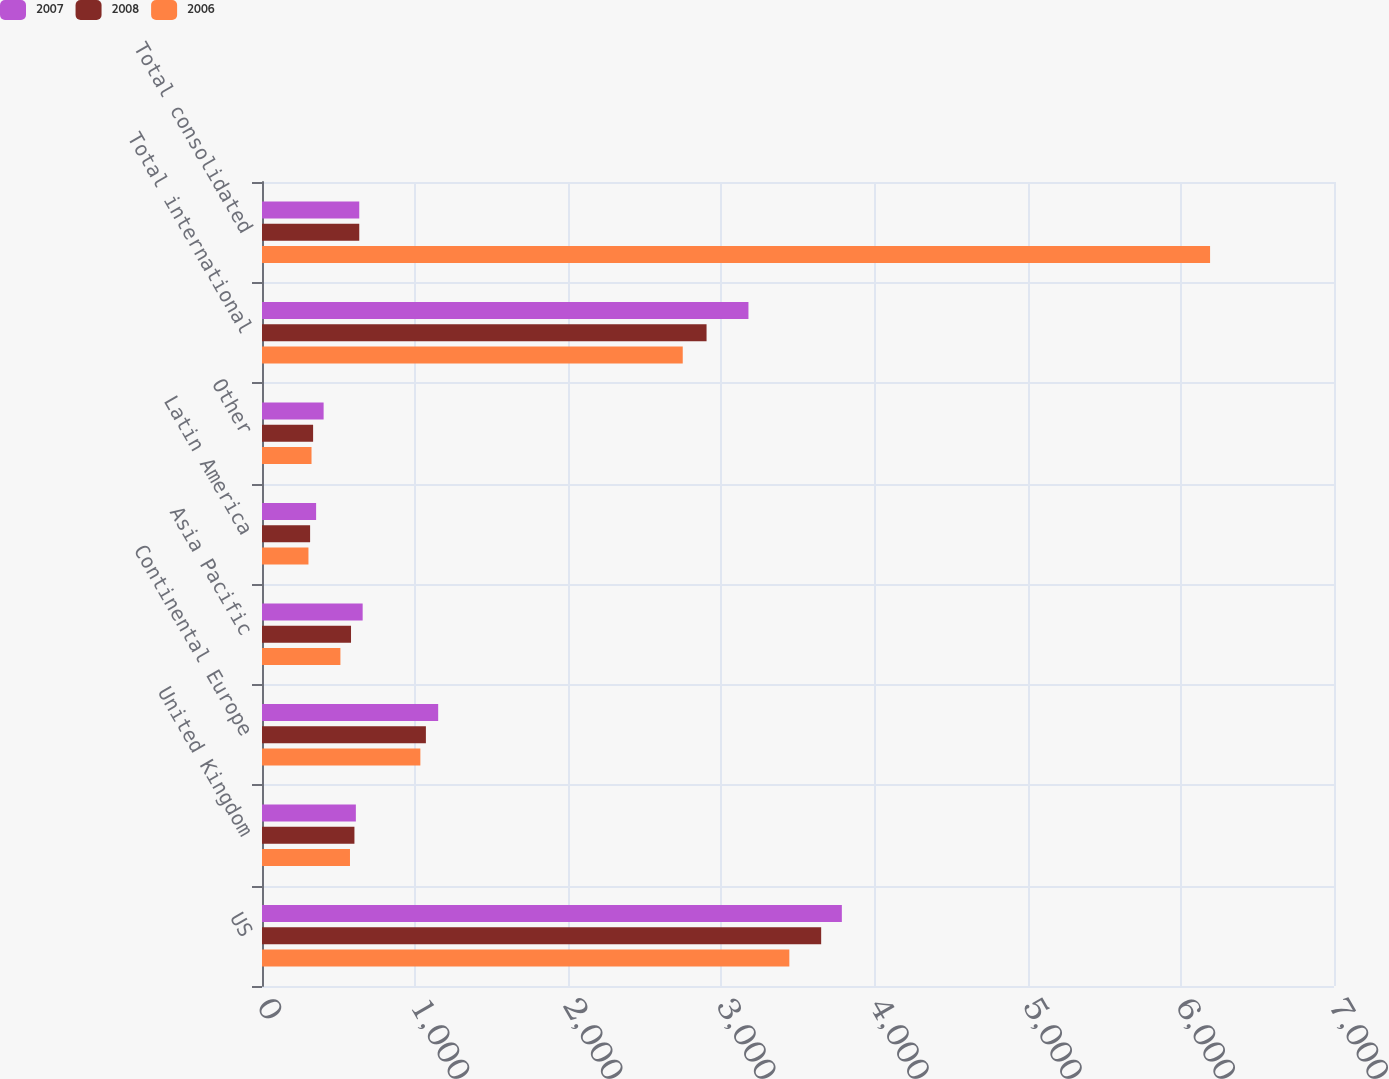Convert chart. <chart><loc_0><loc_0><loc_500><loc_500><stacked_bar_chart><ecel><fcel>US<fcel>United Kingdom<fcel>Continental Europe<fcel>Asia Pacific<fcel>Latin America<fcel>Other<fcel>Total international<fcel>Total consolidated<nl><fcel>2007<fcel>3786.3<fcel>612.9<fcel>1150.4<fcel>657.3<fcel>353.4<fcel>402.4<fcel>3176.4<fcel>635.1<nl><fcel>2008<fcel>3651.3<fcel>603.6<fcel>1070.2<fcel>581.3<fcel>314.1<fcel>333.7<fcel>2902.9<fcel>635.1<nl><fcel>2006<fcel>3443.4<fcel>574.5<fcel>1034.1<fcel>512<fcel>303.4<fcel>323.4<fcel>2747.4<fcel>6190.8<nl></chart> 